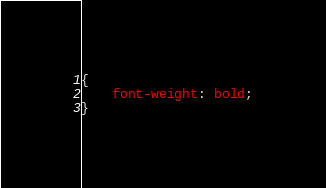Convert code to text. <code><loc_0><loc_0><loc_500><loc_500><_CSS_>{
	font-weight: bold;
}</code> 